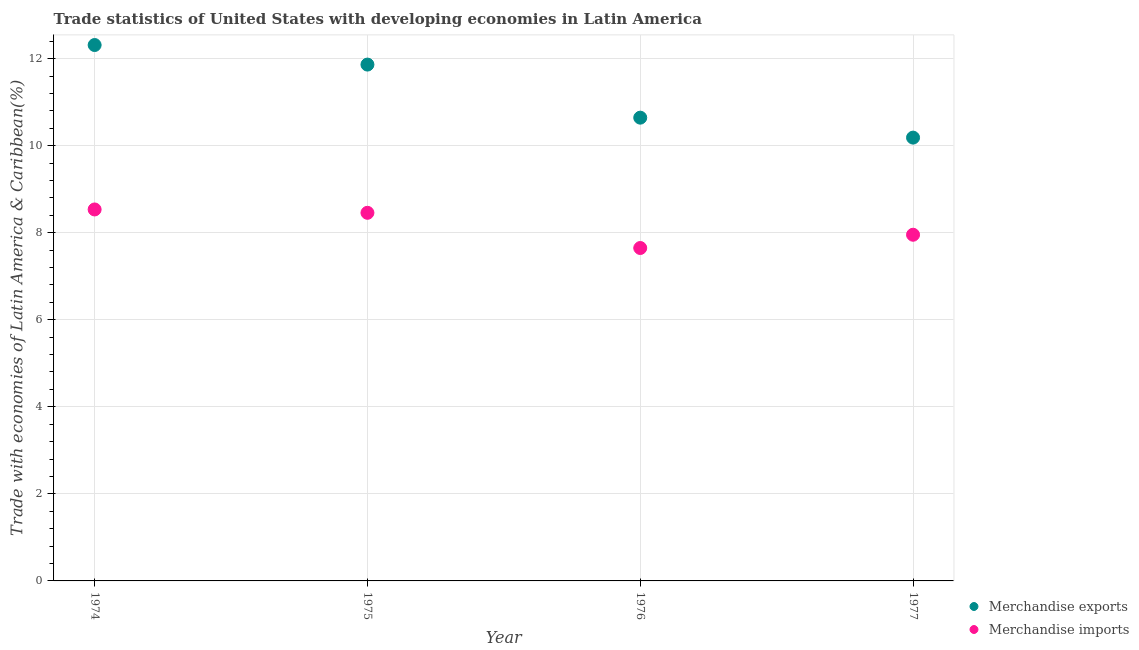What is the merchandise exports in 1977?
Keep it short and to the point. 10.18. Across all years, what is the maximum merchandise exports?
Provide a succinct answer. 12.31. Across all years, what is the minimum merchandise imports?
Give a very brief answer. 7.65. In which year was the merchandise imports maximum?
Your response must be concise. 1974. What is the total merchandise exports in the graph?
Your answer should be compact. 45. What is the difference between the merchandise exports in 1975 and that in 1976?
Your response must be concise. 1.22. What is the difference between the merchandise imports in 1974 and the merchandise exports in 1976?
Give a very brief answer. -2.11. What is the average merchandise imports per year?
Provide a short and direct response. 8.15. In the year 1977, what is the difference between the merchandise exports and merchandise imports?
Your answer should be very brief. 2.23. What is the ratio of the merchandise imports in 1976 to that in 1977?
Your answer should be compact. 0.96. Is the merchandise imports in 1975 less than that in 1976?
Offer a terse response. No. What is the difference between the highest and the second highest merchandise imports?
Make the answer very short. 0.08. What is the difference between the highest and the lowest merchandise exports?
Give a very brief answer. 2.13. Does the graph contain any zero values?
Offer a very short reply. No. Does the graph contain grids?
Your answer should be very brief. Yes. Where does the legend appear in the graph?
Offer a very short reply. Bottom right. How many legend labels are there?
Offer a very short reply. 2. How are the legend labels stacked?
Give a very brief answer. Vertical. What is the title of the graph?
Your response must be concise. Trade statistics of United States with developing economies in Latin America. What is the label or title of the Y-axis?
Provide a short and direct response. Trade with economies of Latin America & Caribbean(%). What is the Trade with economies of Latin America & Caribbean(%) of Merchandise exports in 1974?
Your answer should be very brief. 12.31. What is the Trade with economies of Latin America & Caribbean(%) of Merchandise imports in 1974?
Provide a short and direct response. 8.53. What is the Trade with economies of Latin America & Caribbean(%) in Merchandise exports in 1975?
Provide a short and direct response. 11.86. What is the Trade with economies of Latin America & Caribbean(%) of Merchandise imports in 1975?
Your response must be concise. 8.46. What is the Trade with economies of Latin America & Caribbean(%) of Merchandise exports in 1976?
Make the answer very short. 10.64. What is the Trade with economies of Latin America & Caribbean(%) of Merchandise imports in 1976?
Your response must be concise. 7.65. What is the Trade with economies of Latin America & Caribbean(%) of Merchandise exports in 1977?
Provide a short and direct response. 10.18. What is the Trade with economies of Latin America & Caribbean(%) of Merchandise imports in 1977?
Provide a short and direct response. 7.95. Across all years, what is the maximum Trade with economies of Latin America & Caribbean(%) in Merchandise exports?
Your answer should be compact. 12.31. Across all years, what is the maximum Trade with economies of Latin America & Caribbean(%) of Merchandise imports?
Provide a succinct answer. 8.53. Across all years, what is the minimum Trade with economies of Latin America & Caribbean(%) of Merchandise exports?
Ensure brevity in your answer.  10.18. Across all years, what is the minimum Trade with economies of Latin America & Caribbean(%) of Merchandise imports?
Offer a terse response. 7.65. What is the total Trade with economies of Latin America & Caribbean(%) in Merchandise exports in the graph?
Give a very brief answer. 45. What is the total Trade with economies of Latin America & Caribbean(%) of Merchandise imports in the graph?
Your response must be concise. 32.59. What is the difference between the Trade with economies of Latin America & Caribbean(%) of Merchandise exports in 1974 and that in 1975?
Your answer should be compact. 0.45. What is the difference between the Trade with economies of Latin America & Caribbean(%) of Merchandise imports in 1974 and that in 1975?
Give a very brief answer. 0.08. What is the difference between the Trade with economies of Latin America & Caribbean(%) in Merchandise exports in 1974 and that in 1976?
Make the answer very short. 1.67. What is the difference between the Trade with economies of Latin America & Caribbean(%) of Merchandise imports in 1974 and that in 1976?
Ensure brevity in your answer.  0.89. What is the difference between the Trade with economies of Latin America & Caribbean(%) in Merchandise exports in 1974 and that in 1977?
Make the answer very short. 2.13. What is the difference between the Trade with economies of Latin America & Caribbean(%) of Merchandise imports in 1974 and that in 1977?
Your response must be concise. 0.58. What is the difference between the Trade with economies of Latin America & Caribbean(%) of Merchandise exports in 1975 and that in 1976?
Offer a terse response. 1.22. What is the difference between the Trade with economies of Latin America & Caribbean(%) in Merchandise imports in 1975 and that in 1976?
Ensure brevity in your answer.  0.81. What is the difference between the Trade with economies of Latin America & Caribbean(%) of Merchandise exports in 1975 and that in 1977?
Make the answer very short. 1.68. What is the difference between the Trade with economies of Latin America & Caribbean(%) of Merchandise imports in 1975 and that in 1977?
Provide a succinct answer. 0.5. What is the difference between the Trade with economies of Latin America & Caribbean(%) of Merchandise exports in 1976 and that in 1977?
Your response must be concise. 0.46. What is the difference between the Trade with economies of Latin America & Caribbean(%) of Merchandise imports in 1976 and that in 1977?
Make the answer very short. -0.3. What is the difference between the Trade with economies of Latin America & Caribbean(%) in Merchandise exports in 1974 and the Trade with economies of Latin America & Caribbean(%) in Merchandise imports in 1975?
Offer a terse response. 3.85. What is the difference between the Trade with economies of Latin America & Caribbean(%) of Merchandise exports in 1974 and the Trade with economies of Latin America & Caribbean(%) of Merchandise imports in 1976?
Provide a short and direct response. 4.66. What is the difference between the Trade with economies of Latin America & Caribbean(%) in Merchandise exports in 1974 and the Trade with economies of Latin America & Caribbean(%) in Merchandise imports in 1977?
Your answer should be compact. 4.36. What is the difference between the Trade with economies of Latin America & Caribbean(%) in Merchandise exports in 1975 and the Trade with economies of Latin America & Caribbean(%) in Merchandise imports in 1976?
Provide a succinct answer. 4.21. What is the difference between the Trade with economies of Latin America & Caribbean(%) of Merchandise exports in 1975 and the Trade with economies of Latin America & Caribbean(%) of Merchandise imports in 1977?
Offer a very short reply. 3.91. What is the difference between the Trade with economies of Latin America & Caribbean(%) in Merchandise exports in 1976 and the Trade with economies of Latin America & Caribbean(%) in Merchandise imports in 1977?
Ensure brevity in your answer.  2.69. What is the average Trade with economies of Latin America & Caribbean(%) in Merchandise exports per year?
Make the answer very short. 11.25. What is the average Trade with economies of Latin America & Caribbean(%) in Merchandise imports per year?
Make the answer very short. 8.15. In the year 1974, what is the difference between the Trade with economies of Latin America & Caribbean(%) in Merchandise exports and Trade with economies of Latin America & Caribbean(%) in Merchandise imports?
Offer a very short reply. 3.78. In the year 1975, what is the difference between the Trade with economies of Latin America & Caribbean(%) in Merchandise exports and Trade with economies of Latin America & Caribbean(%) in Merchandise imports?
Your answer should be very brief. 3.41. In the year 1976, what is the difference between the Trade with economies of Latin America & Caribbean(%) of Merchandise exports and Trade with economies of Latin America & Caribbean(%) of Merchandise imports?
Provide a succinct answer. 2.99. In the year 1977, what is the difference between the Trade with economies of Latin America & Caribbean(%) of Merchandise exports and Trade with economies of Latin America & Caribbean(%) of Merchandise imports?
Your answer should be very brief. 2.23. What is the ratio of the Trade with economies of Latin America & Caribbean(%) in Merchandise exports in 1974 to that in 1975?
Keep it short and to the point. 1.04. What is the ratio of the Trade with economies of Latin America & Caribbean(%) in Merchandise imports in 1974 to that in 1975?
Give a very brief answer. 1.01. What is the ratio of the Trade with economies of Latin America & Caribbean(%) of Merchandise exports in 1974 to that in 1976?
Your response must be concise. 1.16. What is the ratio of the Trade with economies of Latin America & Caribbean(%) in Merchandise imports in 1974 to that in 1976?
Provide a short and direct response. 1.12. What is the ratio of the Trade with economies of Latin America & Caribbean(%) in Merchandise exports in 1974 to that in 1977?
Offer a very short reply. 1.21. What is the ratio of the Trade with economies of Latin America & Caribbean(%) in Merchandise imports in 1974 to that in 1977?
Make the answer very short. 1.07. What is the ratio of the Trade with economies of Latin America & Caribbean(%) in Merchandise exports in 1975 to that in 1976?
Provide a short and direct response. 1.11. What is the ratio of the Trade with economies of Latin America & Caribbean(%) in Merchandise imports in 1975 to that in 1976?
Your answer should be compact. 1.11. What is the ratio of the Trade with economies of Latin America & Caribbean(%) in Merchandise exports in 1975 to that in 1977?
Give a very brief answer. 1.16. What is the ratio of the Trade with economies of Latin America & Caribbean(%) of Merchandise imports in 1975 to that in 1977?
Your response must be concise. 1.06. What is the ratio of the Trade with economies of Latin America & Caribbean(%) of Merchandise exports in 1976 to that in 1977?
Offer a very short reply. 1.04. What is the ratio of the Trade with economies of Latin America & Caribbean(%) in Merchandise imports in 1976 to that in 1977?
Offer a very short reply. 0.96. What is the difference between the highest and the second highest Trade with economies of Latin America & Caribbean(%) of Merchandise exports?
Your answer should be compact. 0.45. What is the difference between the highest and the second highest Trade with economies of Latin America & Caribbean(%) in Merchandise imports?
Provide a short and direct response. 0.08. What is the difference between the highest and the lowest Trade with economies of Latin America & Caribbean(%) in Merchandise exports?
Your answer should be very brief. 2.13. What is the difference between the highest and the lowest Trade with economies of Latin America & Caribbean(%) of Merchandise imports?
Provide a succinct answer. 0.89. 